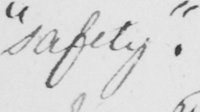Please provide the text content of this handwritten line. " safety "  . 